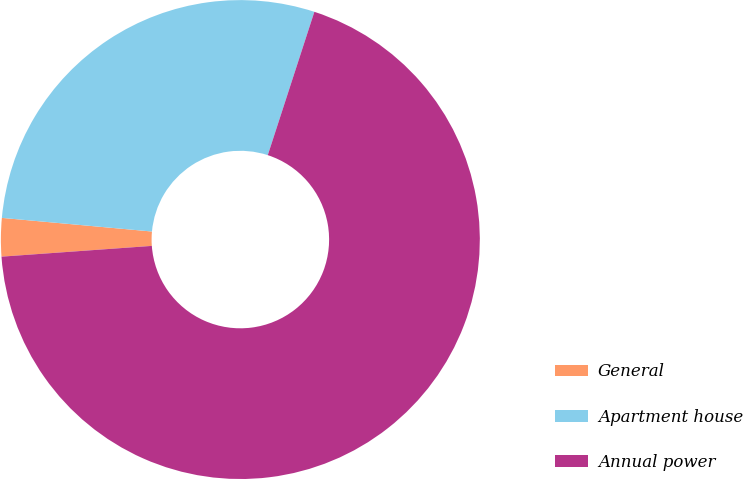<chart> <loc_0><loc_0><loc_500><loc_500><pie_chart><fcel>General<fcel>Apartment house<fcel>Annual power<nl><fcel>2.58%<fcel>28.56%<fcel>68.86%<nl></chart> 